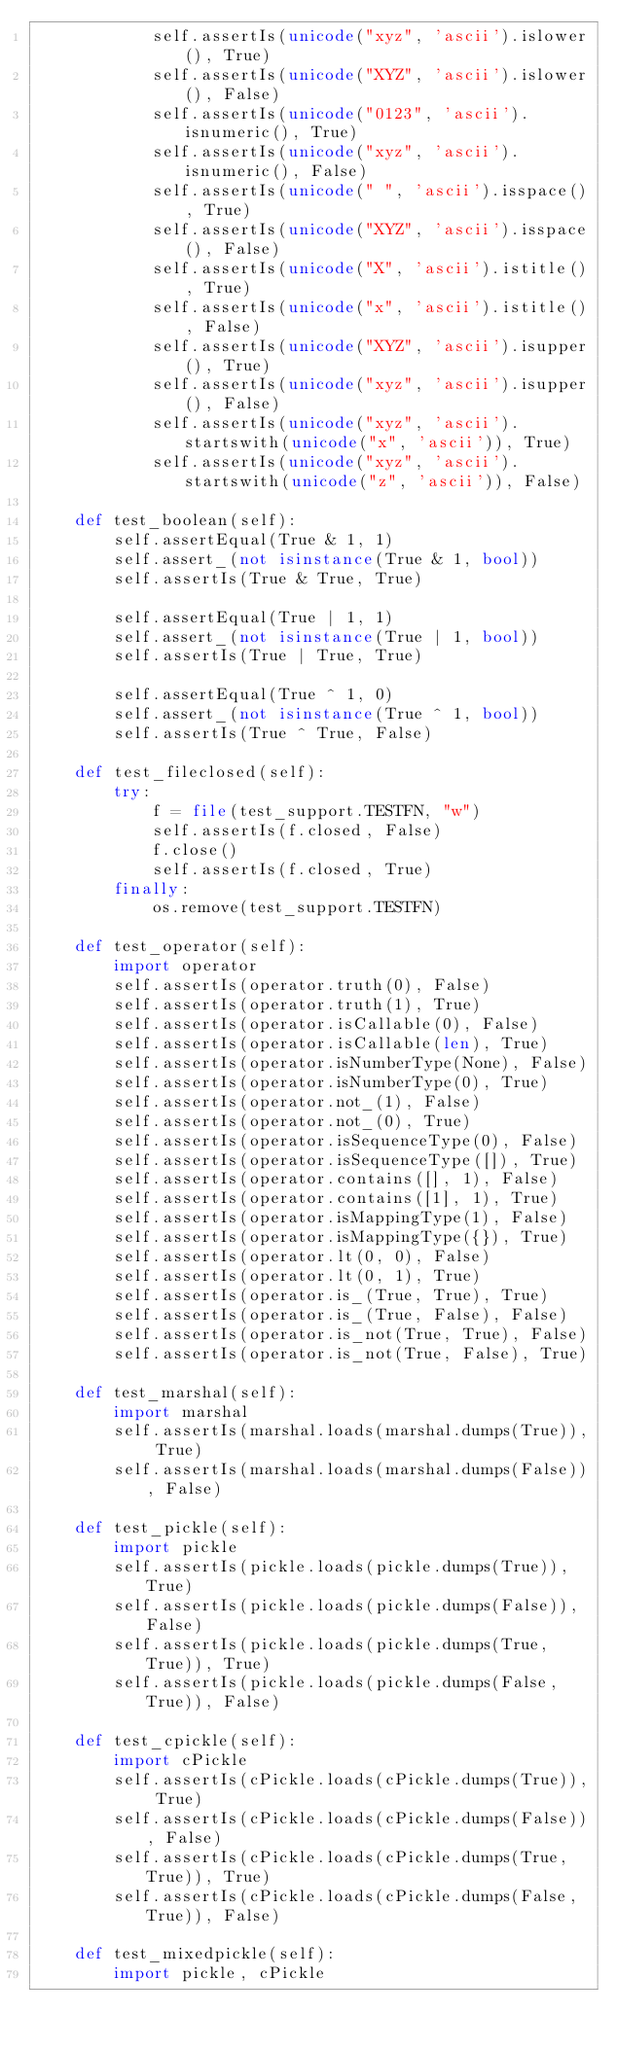<code> <loc_0><loc_0><loc_500><loc_500><_Python_>            self.assertIs(unicode("xyz", 'ascii').islower(), True)
            self.assertIs(unicode("XYZ", 'ascii').islower(), False)
            self.assertIs(unicode("0123", 'ascii').isnumeric(), True)
            self.assertIs(unicode("xyz", 'ascii').isnumeric(), False)
            self.assertIs(unicode(" ", 'ascii').isspace(), True)
            self.assertIs(unicode("XYZ", 'ascii').isspace(), False)
            self.assertIs(unicode("X", 'ascii').istitle(), True)
            self.assertIs(unicode("x", 'ascii').istitle(), False)
            self.assertIs(unicode("XYZ", 'ascii').isupper(), True)
            self.assertIs(unicode("xyz", 'ascii').isupper(), False)
            self.assertIs(unicode("xyz", 'ascii').startswith(unicode("x", 'ascii')), True)
            self.assertIs(unicode("xyz", 'ascii').startswith(unicode("z", 'ascii')), False)

    def test_boolean(self):
        self.assertEqual(True & 1, 1)
        self.assert_(not isinstance(True & 1, bool))
        self.assertIs(True & True, True)

        self.assertEqual(True | 1, 1)
        self.assert_(not isinstance(True | 1, bool))
        self.assertIs(True | True, True)

        self.assertEqual(True ^ 1, 0)
        self.assert_(not isinstance(True ^ 1, bool))
        self.assertIs(True ^ True, False)

    def test_fileclosed(self):
        try:
            f = file(test_support.TESTFN, "w")
            self.assertIs(f.closed, False)
            f.close()
            self.assertIs(f.closed, True)
        finally:
            os.remove(test_support.TESTFN)

    def test_operator(self):
        import operator
        self.assertIs(operator.truth(0), False)
        self.assertIs(operator.truth(1), True)
        self.assertIs(operator.isCallable(0), False)
        self.assertIs(operator.isCallable(len), True)
        self.assertIs(operator.isNumberType(None), False)
        self.assertIs(operator.isNumberType(0), True)
        self.assertIs(operator.not_(1), False)
        self.assertIs(operator.not_(0), True)
        self.assertIs(operator.isSequenceType(0), False)
        self.assertIs(operator.isSequenceType([]), True)
        self.assertIs(operator.contains([], 1), False)
        self.assertIs(operator.contains([1], 1), True)
        self.assertIs(operator.isMappingType(1), False)
        self.assertIs(operator.isMappingType({}), True)
        self.assertIs(operator.lt(0, 0), False)
        self.assertIs(operator.lt(0, 1), True)
        self.assertIs(operator.is_(True, True), True)
        self.assertIs(operator.is_(True, False), False)
        self.assertIs(operator.is_not(True, True), False)
        self.assertIs(operator.is_not(True, False), True)

    def test_marshal(self):
        import marshal
        self.assertIs(marshal.loads(marshal.dumps(True)), True)
        self.assertIs(marshal.loads(marshal.dumps(False)), False)

    def test_pickle(self):
        import pickle
        self.assertIs(pickle.loads(pickle.dumps(True)), True)
        self.assertIs(pickle.loads(pickle.dumps(False)), False)
        self.assertIs(pickle.loads(pickle.dumps(True, True)), True)
        self.assertIs(pickle.loads(pickle.dumps(False, True)), False)

    def test_cpickle(self):
        import cPickle
        self.assertIs(cPickle.loads(cPickle.dumps(True)), True)
        self.assertIs(cPickle.loads(cPickle.dumps(False)), False)
        self.assertIs(cPickle.loads(cPickle.dumps(True, True)), True)
        self.assertIs(cPickle.loads(cPickle.dumps(False, True)), False)

    def test_mixedpickle(self):
        import pickle, cPickle</code> 